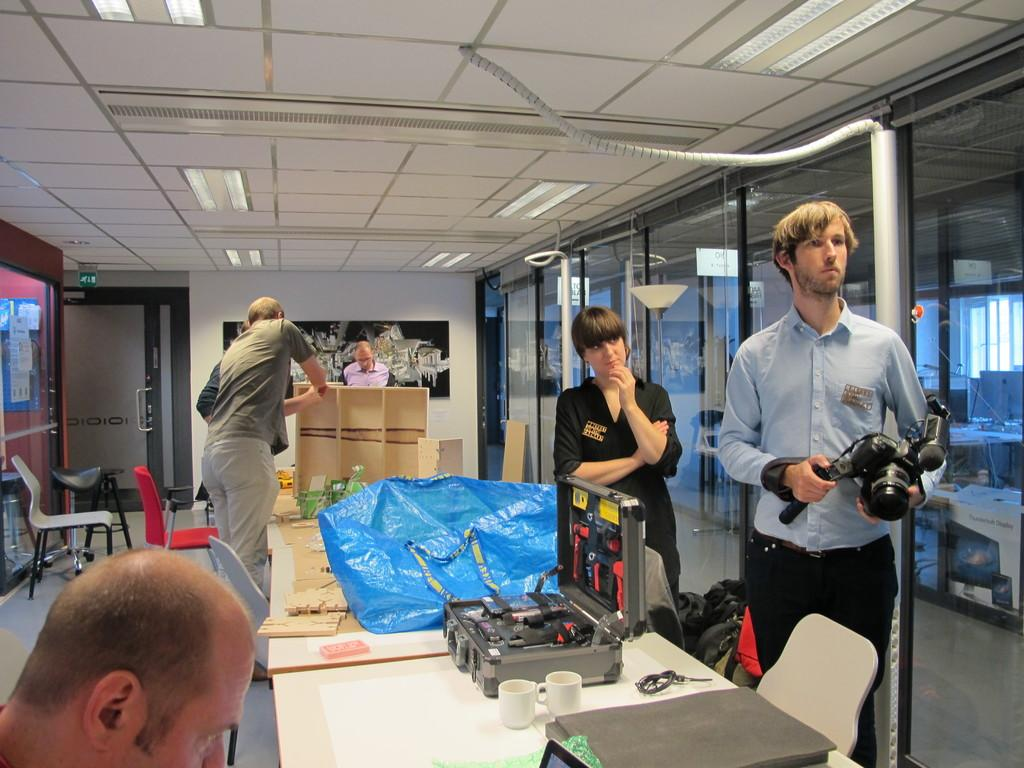Who is present in the image? There are people in the image. What are the people doing in the image? The people are standing in the image. What objects are the people holding in their hands? The people are holding cameras in their hands. What type of plate is being used to take a picture in the image? There is no plate present in the image; the people are holding cameras in their hands. 